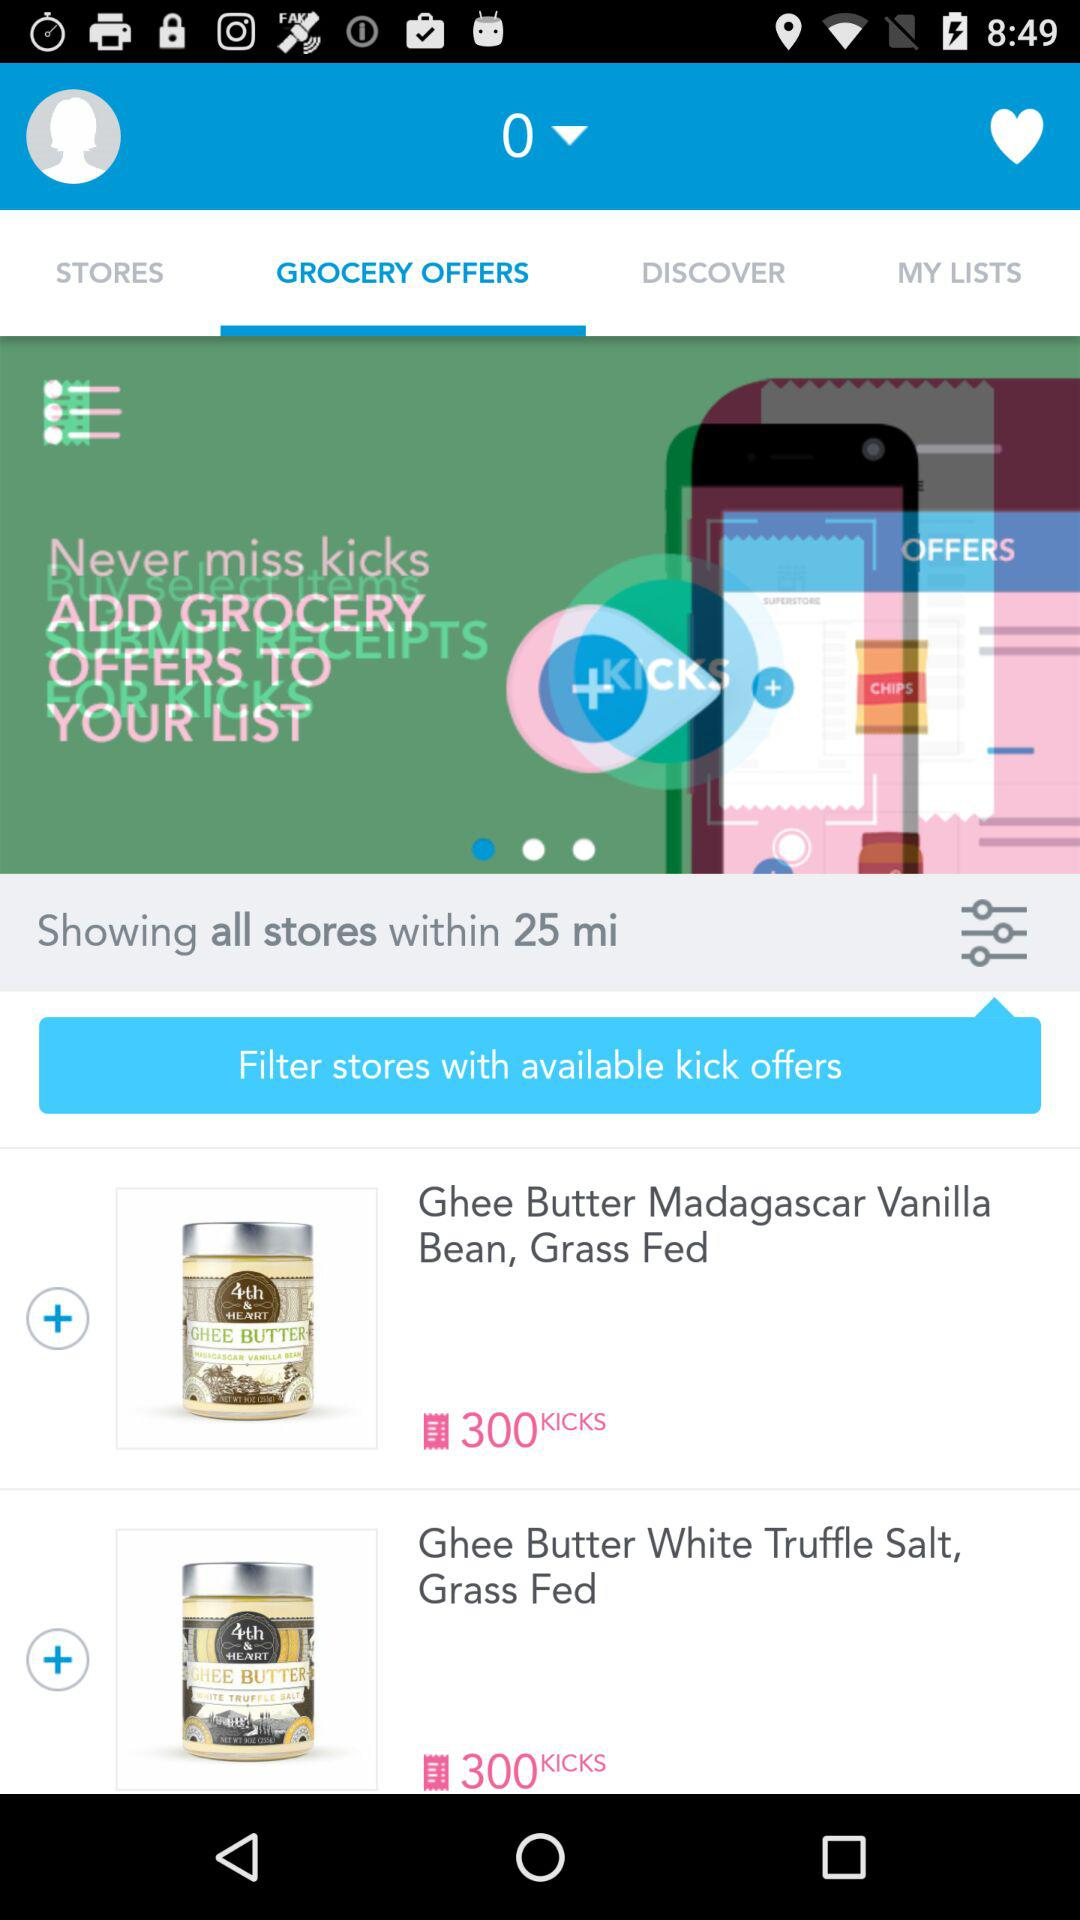How many grocery offers are there?
Answer the question using a single word or phrase. 2 